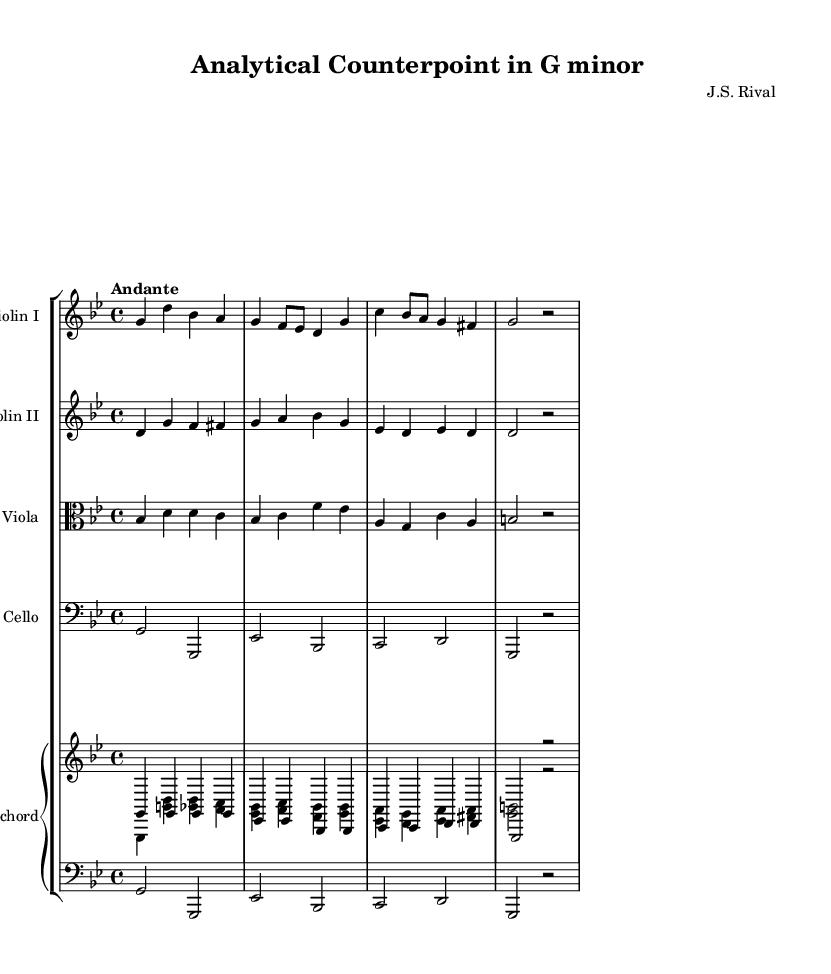What is the key signature of this music? The key signature is G minor, which has two flats (B-flat and E-flat). You can determine this by looking for the key signature markings at the beginning of the staff, where the flats are indicated.
Answer: G minor What is the time signature of this music? The time signature is 4/4, which is indicated at the beginning of the score. This means there are four beats in each measure, and the quarter note gets one beat.
Answer: 4/4 What is the tempo marking of this music? The tempo marking is "Andante," which is a term that indicates a moderate walking pace. This can be found written above the staff, indicating the intended speed of the piece.
Answer: Andante How many instruments are in this piece? There are five instruments listed in this piece: two violins, one viola, one cello, and one harpsichord. Each is represented by its own staff in the score.
Answer: Five In what style does this music belong? The music belongs to the Baroque style, which is characterized by its expressive melodies, intricate counterpoint, and use of ornamentation. Since this piece is written for string instruments and harpsichord, it reflects common features of Baroque chamber music.
Answer: Baroque What is the motive in the first violin part? The motive in the first violin part is a descending figure: starting from G and moving downwards through D and B-flat, consistently outlining the key's harmonic structure. This can be identified by analyzing the notes in the first few measures of the violin I staff.
Answer: Descending figure 